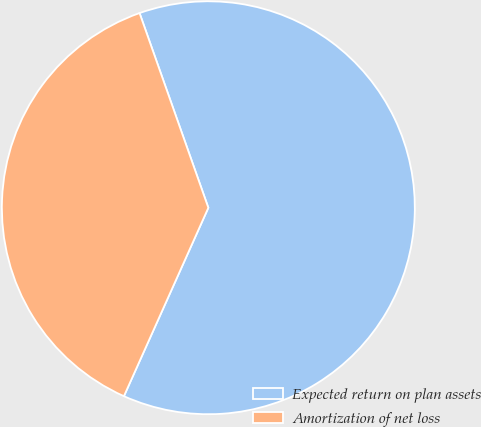Convert chart to OTSL. <chart><loc_0><loc_0><loc_500><loc_500><pie_chart><fcel>Expected return on plan assets<fcel>Amortization of net loss<nl><fcel>62.11%<fcel>37.89%<nl></chart> 